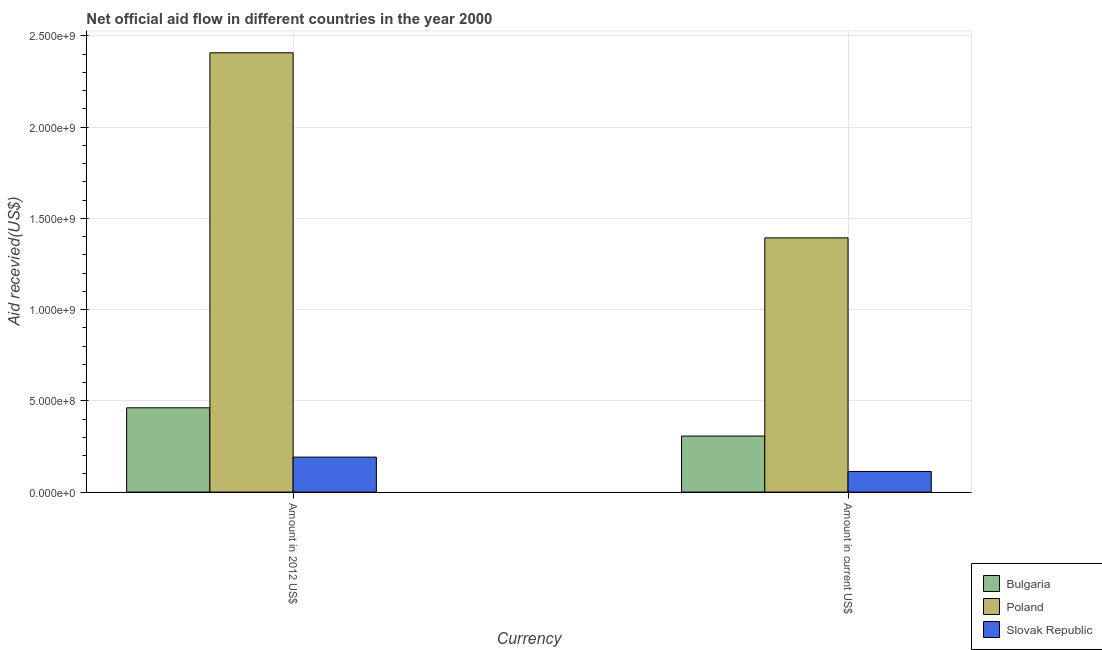How many different coloured bars are there?
Give a very brief answer. 3. Are the number of bars per tick equal to the number of legend labels?
Provide a short and direct response. Yes. How many bars are there on the 1st tick from the right?
Make the answer very short. 3. What is the label of the 1st group of bars from the left?
Give a very brief answer. Amount in 2012 US$. What is the amount of aid received(expressed in us$) in Poland?
Ensure brevity in your answer.  1.39e+09. Across all countries, what is the maximum amount of aid received(expressed in 2012 us$)?
Provide a short and direct response. 2.41e+09. Across all countries, what is the minimum amount of aid received(expressed in 2012 us$)?
Make the answer very short. 1.92e+08. In which country was the amount of aid received(expressed in us$) minimum?
Give a very brief answer. Slovak Republic. What is the total amount of aid received(expressed in us$) in the graph?
Provide a succinct answer. 1.81e+09. What is the difference between the amount of aid received(expressed in 2012 us$) in Poland and that in Bulgaria?
Ensure brevity in your answer.  1.95e+09. What is the difference between the amount of aid received(expressed in us$) in Slovak Republic and the amount of aid received(expressed in 2012 us$) in Bulgaria?
Provide a succinct answer. -3.49e+08. What is the average amount of aid received(expressed in 2012 us$) per country?
Your response must be concise. 1.02e+09. What is the difference between the amount of aid received(expressed in 2012 us$) and amount of aid received(expressed in us$) in Slovak Republic?
Offer a very short reply. 7.87e+07. In how many countries, is the amount of aid received(expressed in us$) greater than 700000000 US$?
Give a very brief answer. 1. What is the ratio of the amount of aid received(expressed in 2012 us$) in Bulgaria to that in Poland?
Provide a succinct answer. 0.19. Is the amount of aid received(expressed in 2012 us$) in Poland less than that in Bulgaria?
Keep it short and to the point. No. What does the 3rd bar from the left in Amount in 2012 US$ represents?
Your response must be concise. Slovak Republic. What does the 2nd bar from the right in Amount in 2012 US$ represents?
Keep it short and to the point. Poland. How many countries are there in the graph?
Your answer should be compact. 3. What is the difference between two consecutive major ticks on the Y-axis?
Your response must be concise. 5.00e+08. Does the graph contain grids?
Your answer should be compact. Yes. What is the title of the graph?
Ensure brevity in your answer.  Net official aid flow in different countries in the year 2000. Does "Andorra" appear as one of the legend labels in the graph?
Keep it short and to the point. No. What is the label or title of the X-axis?
Give a very brief answer. Currency. What is the label or title of the Y-axis?
Keep it short and to the point. Aid recevied(US$). What is the Aid recevied(US$) of Bulgaria in Amount in 2012 US$?
Make the answer very short. 4.62e+08. What is the Aid recevied(US$) in Poland in Amount in 2012 US$?
Your response must be concise. 2.41e+09. What is the Aid recevied(US$) in Slovak Republic in Amount in 2012 US$?
Give a very brief answer. 1.92e+08. What is the Aid recevied(US$) of Bulgaria in Amount in current US$?
Give a very brief answer. 3.07e+08. What is the Aid recevied(US$) in Poland in Amount in current US$?
Provide a short and direct response. 1.39e+09. What is the Aid recevied(US$) of Slovak Republic in Amount in current US$?
Provide a short and direct response. 1.13e+08. Across all Currency, what is the maximum Aid recevied(US$) in Bulgaria?
Keep it short and to the point. 4.62e+08. Across all Currency, what is the maximum Aid recevied(US$) of Poland?
Make the answer very short. 2.41e+09. Across all Currency, what is the maximum Aid recevied(US$) in Slovak Republic?
Give a very brief answer. 1.92e+08. Across all Currency, what is the minimum Aid recevied(US$) of Bulgaria?
Give a very brief answer. 3.07e+08. Across all Currency, what is the minimum Aid recevied(US$) of Poland?
Offer a very short reply. 1.39e+09. Across all Currency, what is the minimum Aid recevied(US$) in Slovak Republic?
Your answer should be very brief. 1.13e+08. What is the total Aid recevied(US$) of Bulgaria in the graph?
Ensure brevity in your answer.  7.69e+08. What is the total Aid recevied(US$) in Poland in the graph?
Provide a short and direct response. 3.80e+09. What is the total Aid recevied(US$) in Slovak Republic in the graph?
Ensure brevity in your answer.  3.05e+08. What is the difference between the Aid recevied(US$) in Bulgaria in Amount in 2012 US$ and that in Amount in current US$?
Give a very brief answer. 1.55e+08. What is the difference between the Aid recevied(US$) in Poland in Amount in 2012 US$ and that in Amount in current US$?
Your response must be concise. 1.01e+09. What is the difference between the Aid recevied(US$) of Slovak Republic in Amount in 2012 US$ and that in Amount in current US$?
Offer a terse response. 7.87e+07. What is the difference between the Aid recevied(US$) of Bulgaria in Amount in 2012 US$ and the Aid recevied(US$) of Poland in Amount in current US$?
Offer a terse response. -9.31e+08. What is the difference between the Aid recevied(US$) in Bulgaria in Amount in 2012 US$ and the Aid recevied(US$) in Slovak Republic in Amount in current US$?
Give a very brief answer. 3.49e+08. What is the difference between the Aid recevied(US$) in Poland in Amount in 2012 US$ and the Aid recevied(US$) in Slovak Republic in Amount in current US$?
Offer a very short reply. 2.29e+09. What is the average Aid recevied(US$) of Bulgaria per Currency?
Provide a succinct answer. 3.85e+08. What is the average Aid recevied(US$) in Poland per Currency?
Offer a terse response. 1.90e+09. What is the average Aid recevied(US$) of Slovak Republic per Currency?
Provide a succinct answer. 1.52e+08. What is the difference between the Aid recevied(US$) of Bulgaria and Aid recevied(US$) of Poland in Amount in 2012 US$?
Give a very brief answer. -1.95e+09. What is the difference between the Aid recevied(US$) of Bulgaria and Aid recevied(US$) of Slovak Republic in Amount in 2012 US$?
Your answer should be very brief. 2.70e+08. What is the difference between the Aid recevied(US$) in Poland and Aid recevied(US$) in Slovak Republic in Amount in 2012 US$?
Give a very brief answer. 2.22e+09. What is the difference between the Aid recevied(US$) of Bulgaria and Aid recevied(US$) of Poland in Amount in current US$?
Provide a short and direct response. -1.09e+09. What is the difference between the Aid recevied(US$) of Bulgaria and Aid recevied(US$) of Slovak Republic in Amount in current US$?
Ensure brevity in your answer.  1.94e+08. What is the difference between the Aid recevied(US$) in Poland and Aid recevied(US$) in Slovak Republic in Amount in current US$?
Ensure brevity in your answer.  1.28e+09. What is the ratio of the Aid recevied(US$) of Bulgaria in Amount in 2012 US$ to that in Amount in current US$?
Offer a very short reply. 1.5. What is the ratio of the Aid recevied(US$) of Poland in Amount in 2012 US$ to that in Amount in current US$?
Your response must be concise. 1.73. What is the ratio of the Aid recevied(US$) in Slovak Republic in Amount in 2012 US$ to that in Amount in current US$?
Offer a very short reply. 1.7. What is the difference between the highest and the second highest Aid recevied(US$) of Bulgaria?
Ensure brevity in your answer.  1.55e+08. What is the difference between the highest and the second highest Aid recevied(US$) of Poland?
Provide a succinct answer. 1.01e+09. What is the difference between the highest and the second highest Aid recevied(US$) in Slovak Republic?
Give a very brief answer. 7.87e+07. What is the difference between the highest and the lowest Aid recevied(US$) in Bulgaria?
Provide a short and direct response. 1.55e+08. What is the difference between the highest and the lowest Aid recevied(US$) of Poland?
Your answer should be compact. 1.01e+09. What is the difference between the highest and the lowest Aid recevied(US$) in Slovak Republic?
Your response must be concise. 7.87e+07. 